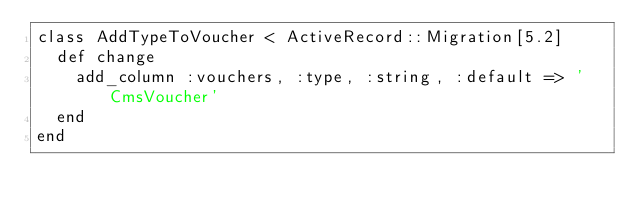Convert code to text. <code><loc_0><loc_0><loc_500><loc_500><_Ruby_>class AddTypeToVoucher < ActiveRecord::Migration[5.2]
  def change
    add_column :vouchers, :type, :string, :default => 'CmsVoucher'
  end
end
</code> 